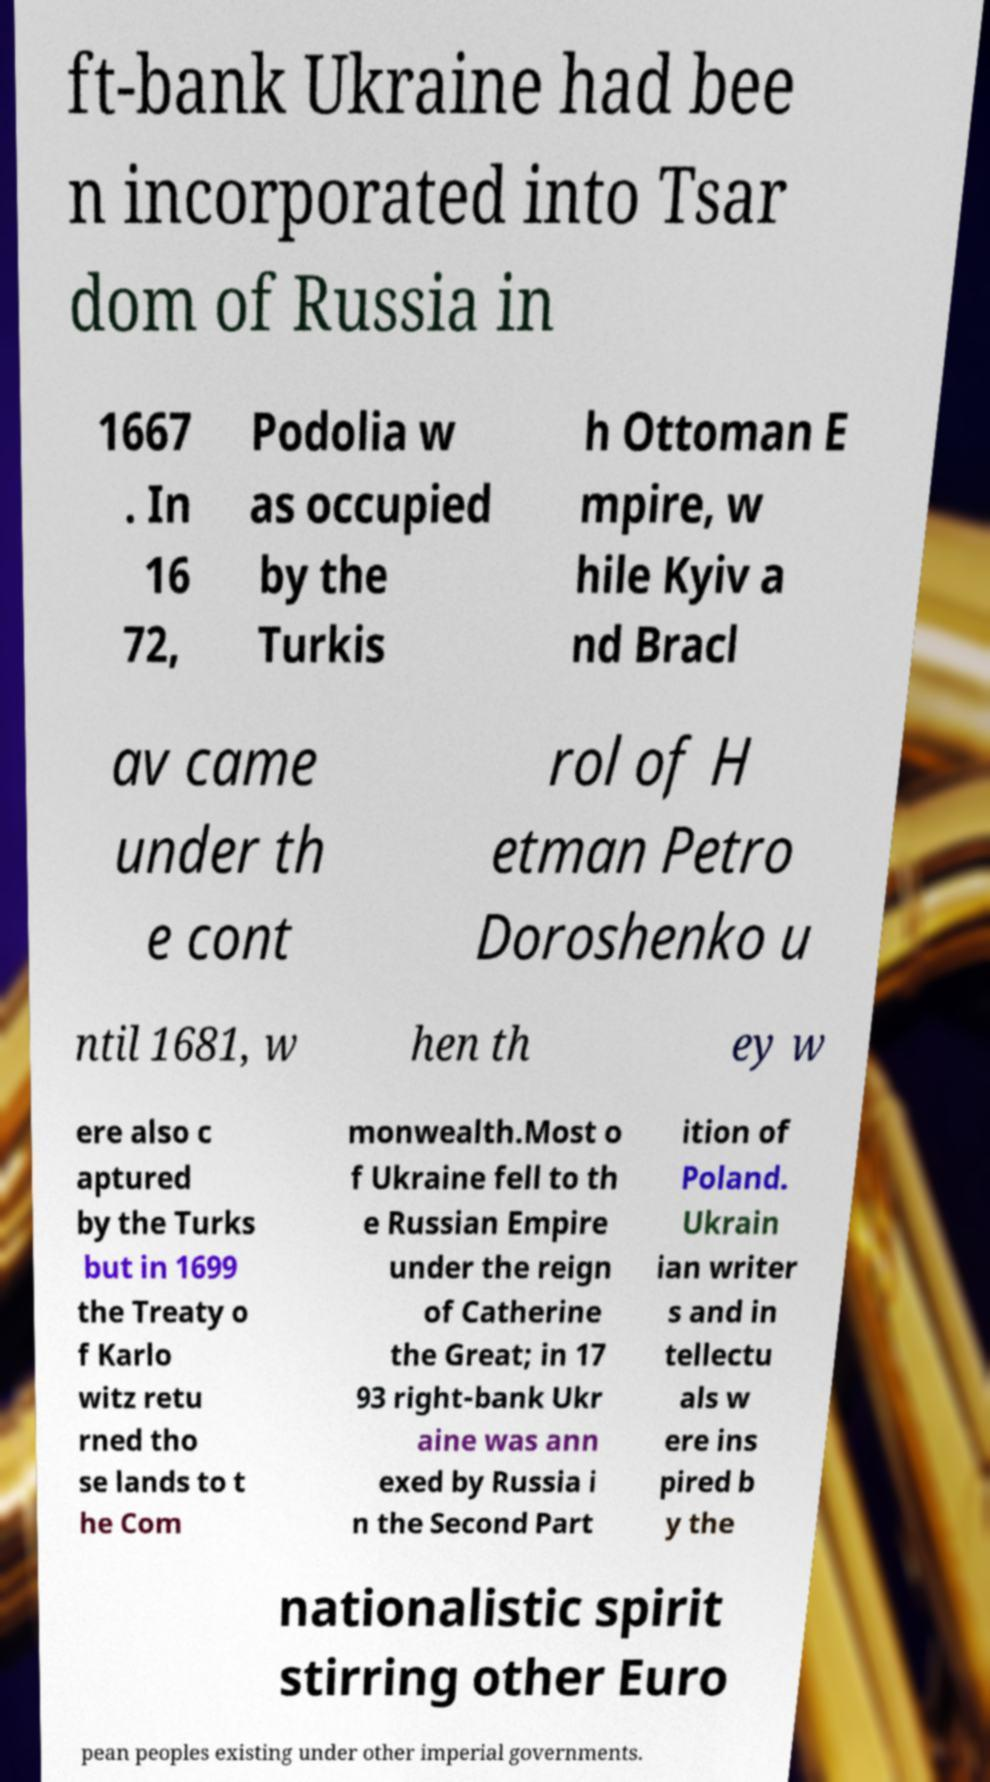Can you accurately transcribe the text from the provided image for me? ft-bank Ukraine had bee n incorporated into Tsar dom of Russia in 1667 . In 16 72, Podolia w as occupied by the Turkis h Ottoman E mpire, w hile Kyiv a nd Bracl av came under th e cont rol of H etman Petro Doroshenko u ntil 1681, w hen th ey w ere also c aptured by the Turks but in 1699 the Treaty o f Karlo witz retu rned tho se lands to t he Com monwealth.Most o f Ukraine fell to th e Russian Empire under the reign of Catherine the Great; in 17 93 right-bank Ukr aine was ann exed by Russia i n the Second Part ition of Poland. Ukrain ian writer s and in tellectu als w ere ins pired b y the nationalistic spirit stirring other Euro pean peoples existing under other imperial governments. 